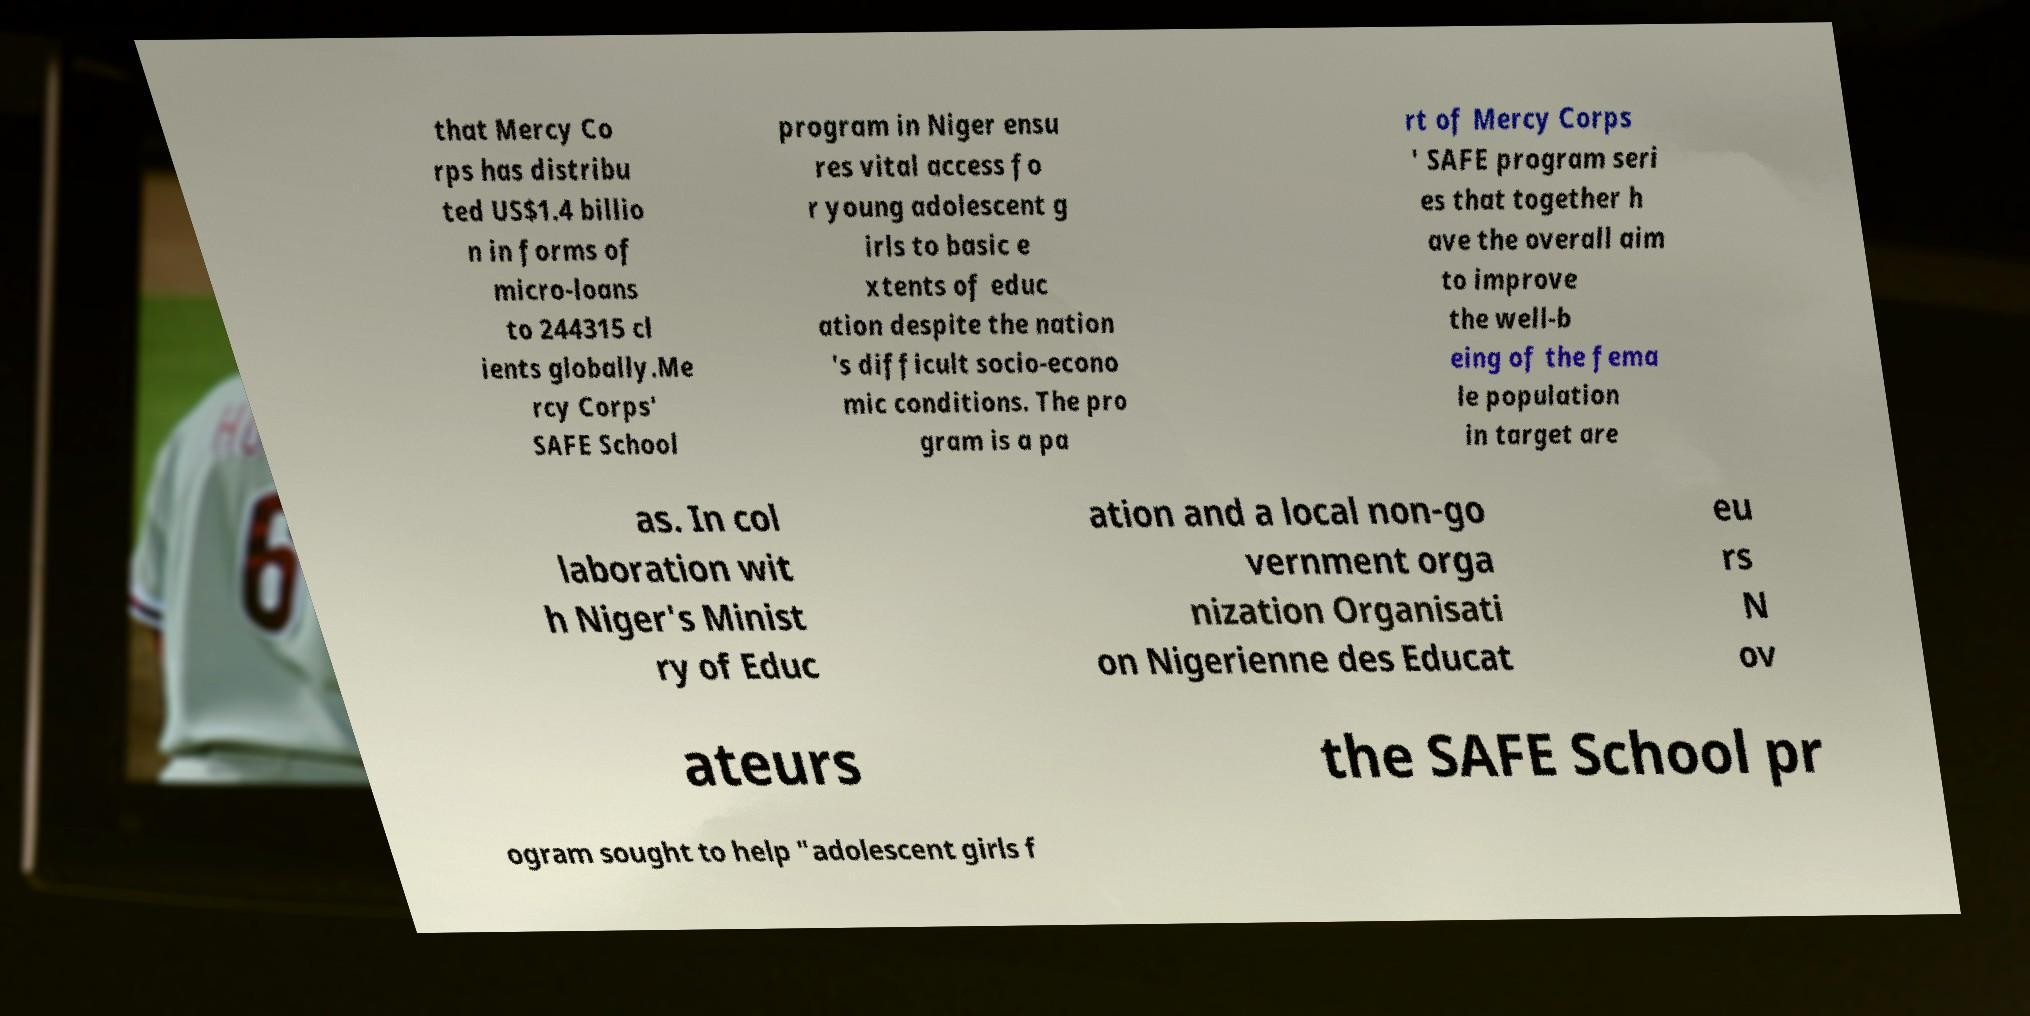I need the written content from this picture converted into text. Can you do that? that Mercy Co rps has distribu ted US$1.4 billio n in forms of micro-loans to 244315 cl ients globally.Me rcy Corps' SAFE School program in Niger ensu res vital access fo r young adolescent g irls to basic e xtents of educ ation despite the nation 's difficult socio-econo mic conditions. The pro gram is a pa rt of Mercy Corps ' SAFE program seri es that together h ave the overall aim to improve the well-b eing of the fema le population in target are as. In col laboration wit h Niger's Minist ry of Educ ation and a local non-go vernment orga nization Organisati on Nigerienne des Educat eu rs N ov ateurs the SAFE School pr ogram sought to help "adolescent girls f 